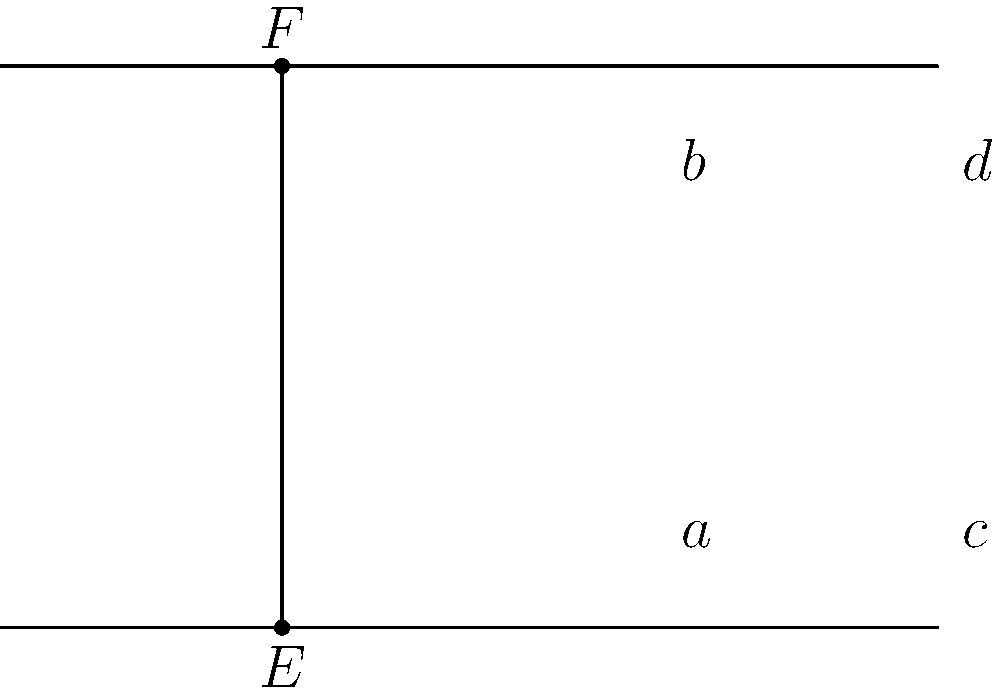In the figure above, two parallel lines are intersected by a transversal. If angle $a = 55°$, what is the measure of angle $d$? Let's approach this step-by-step:

1) First, recall that when a transversal intersects two parallel lines, corresponding angles are congruent. In this case, angles $a$ and $c$ are corresponding angles.

2) Also, remember that when a transversal intersects two parallel lines, alternate interior angles are congruent. Here, angles $c$ and $d$ are alternate interior angles.

3) Given that angle $a = 55°$, and $a$ and $c$ are corresponding angles, we can conclude that angle $c$ is also 55°.

4) Since angles $c$ and $d$ are alternate interior angles, they are congruent. Therefore, angle $d$ must also be 55°.

5) We can verify this by noting that angles on a straight line sum to 180°. So, $a + b = 180°$ and $c + d = 180°$. If $a = c = 55°$, then $b = d = 180° - 55° = 125°$.

Therefore, the measure of angle $d$ is 55°.
Answer: $55°$ 